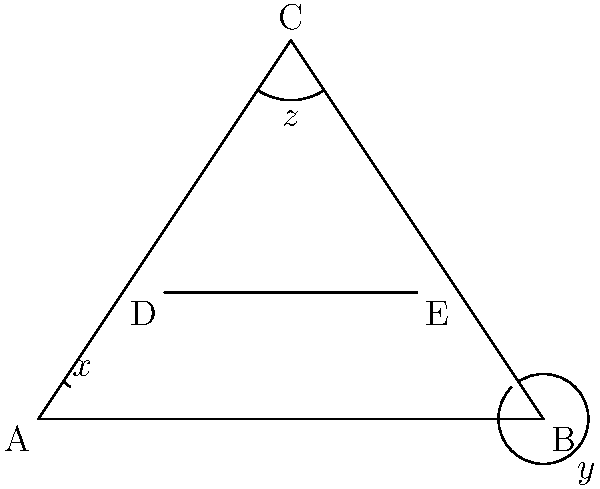In this ancient artifact design, triangle ABC contains a mysterious line segment DE. The angles marked $x$, $y$, and $z$ hold the key to unlocking its secrets. If angle $x$ is congruent to angle $y$, and angle $z$ measures 53°, what is the sum of $x$ and $y$? Let's unravel this mystery step by step:

1) First, we know that angle $x$ is congruent to angle $y$. This means they have the same measure. Let's call this measure $m$.

2) In triangle ABC, we can use the fact that the sum of angles in a triangle is always 180°. So:

   $$x + y + z = 180°$$

3) We're given that $z = 53°$. Let's substitute this:

   $$m + m + 53° = 180°$$
   $$2m + 53° = 180°$$

4) Now, let's solve for $m$:

   $$2m = 180° - 53°$$
   $$2m = 127°$$
   $$m = 63.5°$$

5) Remember, $m$ represents both $x$ and $y$. So:

   $$x = y = 63.5°$$

6) The question asks for the sum of $x$ and $y$:

   $$x + y = 63.5° + 63.5° = 127°$$

Thus, the sum of $x$ and $y$ is 127°.
Answer: 127° 